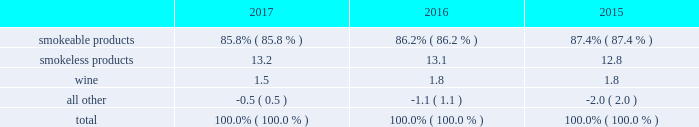10-k altria ar release tuesday , february 27 , 2018 10:00pm andra design llc the relative percentages of operating companies income ( loss ) attributable to each reportable segment and the all other category were as follows: .
For items affecting the comparability of the relative percentages of operating companies income ( loss ) attributable to each reportable segment , see note 15 .
Narrative description of business portions of the information called for by this item are included in operating results by business segment in item 7 .
Management 2019s discussion and analysis of financial condition and results of operations of this annual report on form 10-k ( 201citem 7 201d ) .
Tobacco space altria group , inc . 2019s tobacco operating companies include pm usa , usstc and other subsidiaries of ust , middleton , nu mark and nat sherman .
Altria group distribution company provides sales and distribution services to altria group , inc . 2019s tobacco operating companies .
The products of altria group , inc . 2019s tobacco subsidiaries include smokeable tobacco products , consisting of cigarettes manufactured and sold by pm usa and nat sherman , machine- made large cigars and pipe tobacco manufactured and sold by middleton and premium cigars sold by nat sherman ; smokeless tobacco products manufactured and sold by usstc ; and innovative tobacco products , including e-vapor products manufactured and sold by nu mark .
Cigarettes : pm usa is the largest cigarette company in the united states .
Marlboro , the principal cigarette brand of pm usa , has been the largest-selling cigarette brand in the united states for over 40 years .
Nat sherman sells substantially all of its super premium cigarettes in the united states .
Total smokeable products segment 2019s cigarettes shipment volume in the united states was 116.6 billion units in 2017 , a decrease of 5.1% ( 5.1 % ) from cigars : middleton is engaged in the manufacture and sale of machine-made large cigars and pipe tobacco .
Middleton contracts with a third-party importer to supply a majority of its cigars and sells substantially all of its cigars to customers in the united states .
Black & mild is the principal cigar brand of middleton .
Nat sherman sources all of its cigars from third-party suppliers and sells substantially all of its cigars to customers in the united states .
Total smokeable products segment 2019s cigars shipment volume was approximately 1.5 billion units in 2017 , an increase of 9.9% ( 9.9 % ) from 2016 .
Smokeless tobacco products : usstc is the leading producer and marketer of moist smokeless tobacco ( 201cmst 201d ) products .
The smokeless products segment includes the premium brands , copenhagen and skoal , and value brands , red seal and husky .
Substantially all of the smokeless tobacco products are manufactured and sold to customers in the united states .
Total smokeless products segment 2019s shipment volume was 841.3 million units in 2017 , a decrease of 1.4% ( 1.4 % ) from 2016 .
Innovative tobacco products : nu mark participates in the e-vapor category and has developed and commercialized other innovative tobacco products .
In addition , nu mark sources the production of its e-vapor products through overseas contract manufacturing arrangements .
In 2013 , nu mark introduced markten e-vapor products .
In april 2014 , nu mark acquired the e-vapor business of green smoke , inc .
And its affiliates ( 201cgreen smoke 201d ) , which began selling e-vapor products in 2009 .
In 2017 , altria group , inc . 2019s subsidiaries purchased certain intellectual property related to innovative tobacco products .
In december 2013 , altria group , inc . 2019s subsidiaries entered into a series of agreements with philip morris international inc .
( 201cpmi 201d ) pursuant to which altria group , inc . 2019s subsidiaries provide an exclusive license to pmi to sell nu mark 2019s e-vapor products outside the united states , and pmi 2019s subsidiaries provide an exclusive license to altria group , inc . 2019s subsidiaries to sell two of pmi 2019s heated tobacco product platforms in the united states .
Further , in july 2015 , altria group , inc .
Announced the expansion of its strategic framework with pmi to include a joint research , development and technology-sharing agreement .
Under this agreement , altria group , inc . 2019s subsidiaries and pmi will collaborate to develop e-vapor products for commercialization in the united states by altria group , inc . 2019s subsidiaries and in markets outside the united states by pmi .
This agreement also provides for exclusive technology cross licenses , technical information sharing and cooperation on scientific assessment , regulatory engagement and approval related to e-vapor products .
In the fourth quarter of 2016 , pmi submitted a modified risk tobacco product ( 201cmrtp 201d ) application for an electronically heated tobacco product with the united states food and drug administration 2019s ( 201cfda 201d ) center for tobacco products and filed its corresponding pre-market tobacco product application in the first quarter of 2017 .
Upon regulatory authorization by the fda , altria group , inc . 2019s subsidiaries will have an exclusive license to sell this heated tobacco product in the united states .
Distribution , competition and raw materials : altria group , inc . 2019s tobacco subsidiaries sell their tobacco products principally to wholesalers ( including distributors ) , large retail organizations , including chain stores , and the armed services .
The market for tobacco products is highly competitive , characterized by brand recognition and loyalty , with product quality , taste , price , product innovation , marketing , packaging and distribution constituting the significant methods of competition .
Promotional activities include , in certain instances and where permitted by law , allowances , the distribution of incentive items , price promotions , product promotions , coupons and other discounts. .
What is the percent change in relative percentages of operating companies income ( loss ) attributable to smokeable products from 2015 to 2016? 
Computations: (87.4% - 86.2%)
Answer: 0.012. 